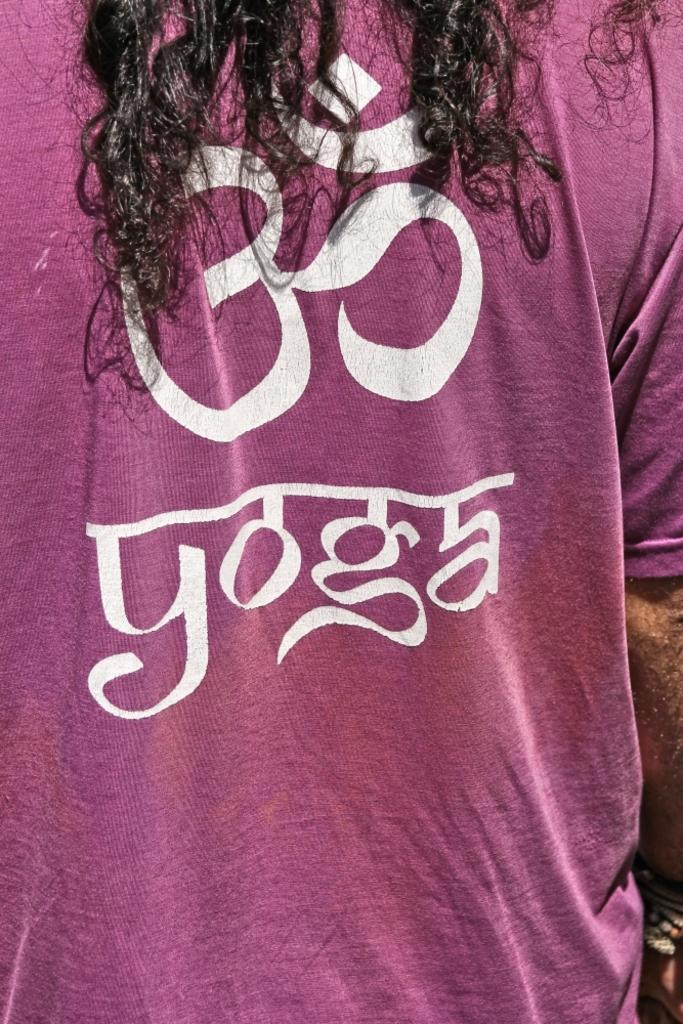What is the main subject in the foreground of the picture? There is a person in the foreground of the picture. What is the person wearing in the picture? The person is wearing a pink T-shirt. What is written on the T-shirt? The T-shirt has the text "YOGA" on it. What else is on the T-shirt besides the text? The T-shirt has a symbol on it. What can be observed about the person's hair in the picture? The person has hair on their head. What type of organization is the person representing in the picture? There is no indication in the image that the person is representing any organization. What kind of pest can be seen crawling on the person's hair in the picture? There are no pests visible in the image, and the person's hair appears to be free of any insects or animals. 